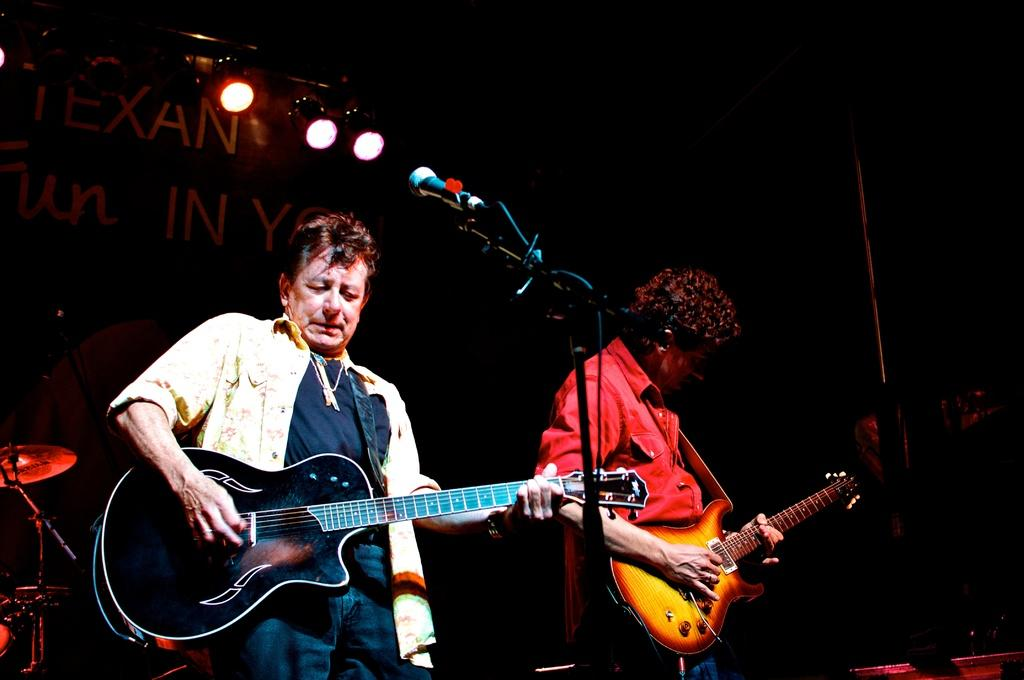How many people are in the image? There are two men in the image. What are the men doing in the image? The men are playing guitars. What object is present in the image that is commonly used for amplifying sound? A microphone is present in the image. How many lights can be seen in the image, and where are they positioned? There are three lights visible in the image, positioned on the men's backs. What word is being sung by the men in the image? There is no way to determine the specific word being sung in the image, as we cannot hear the music. 